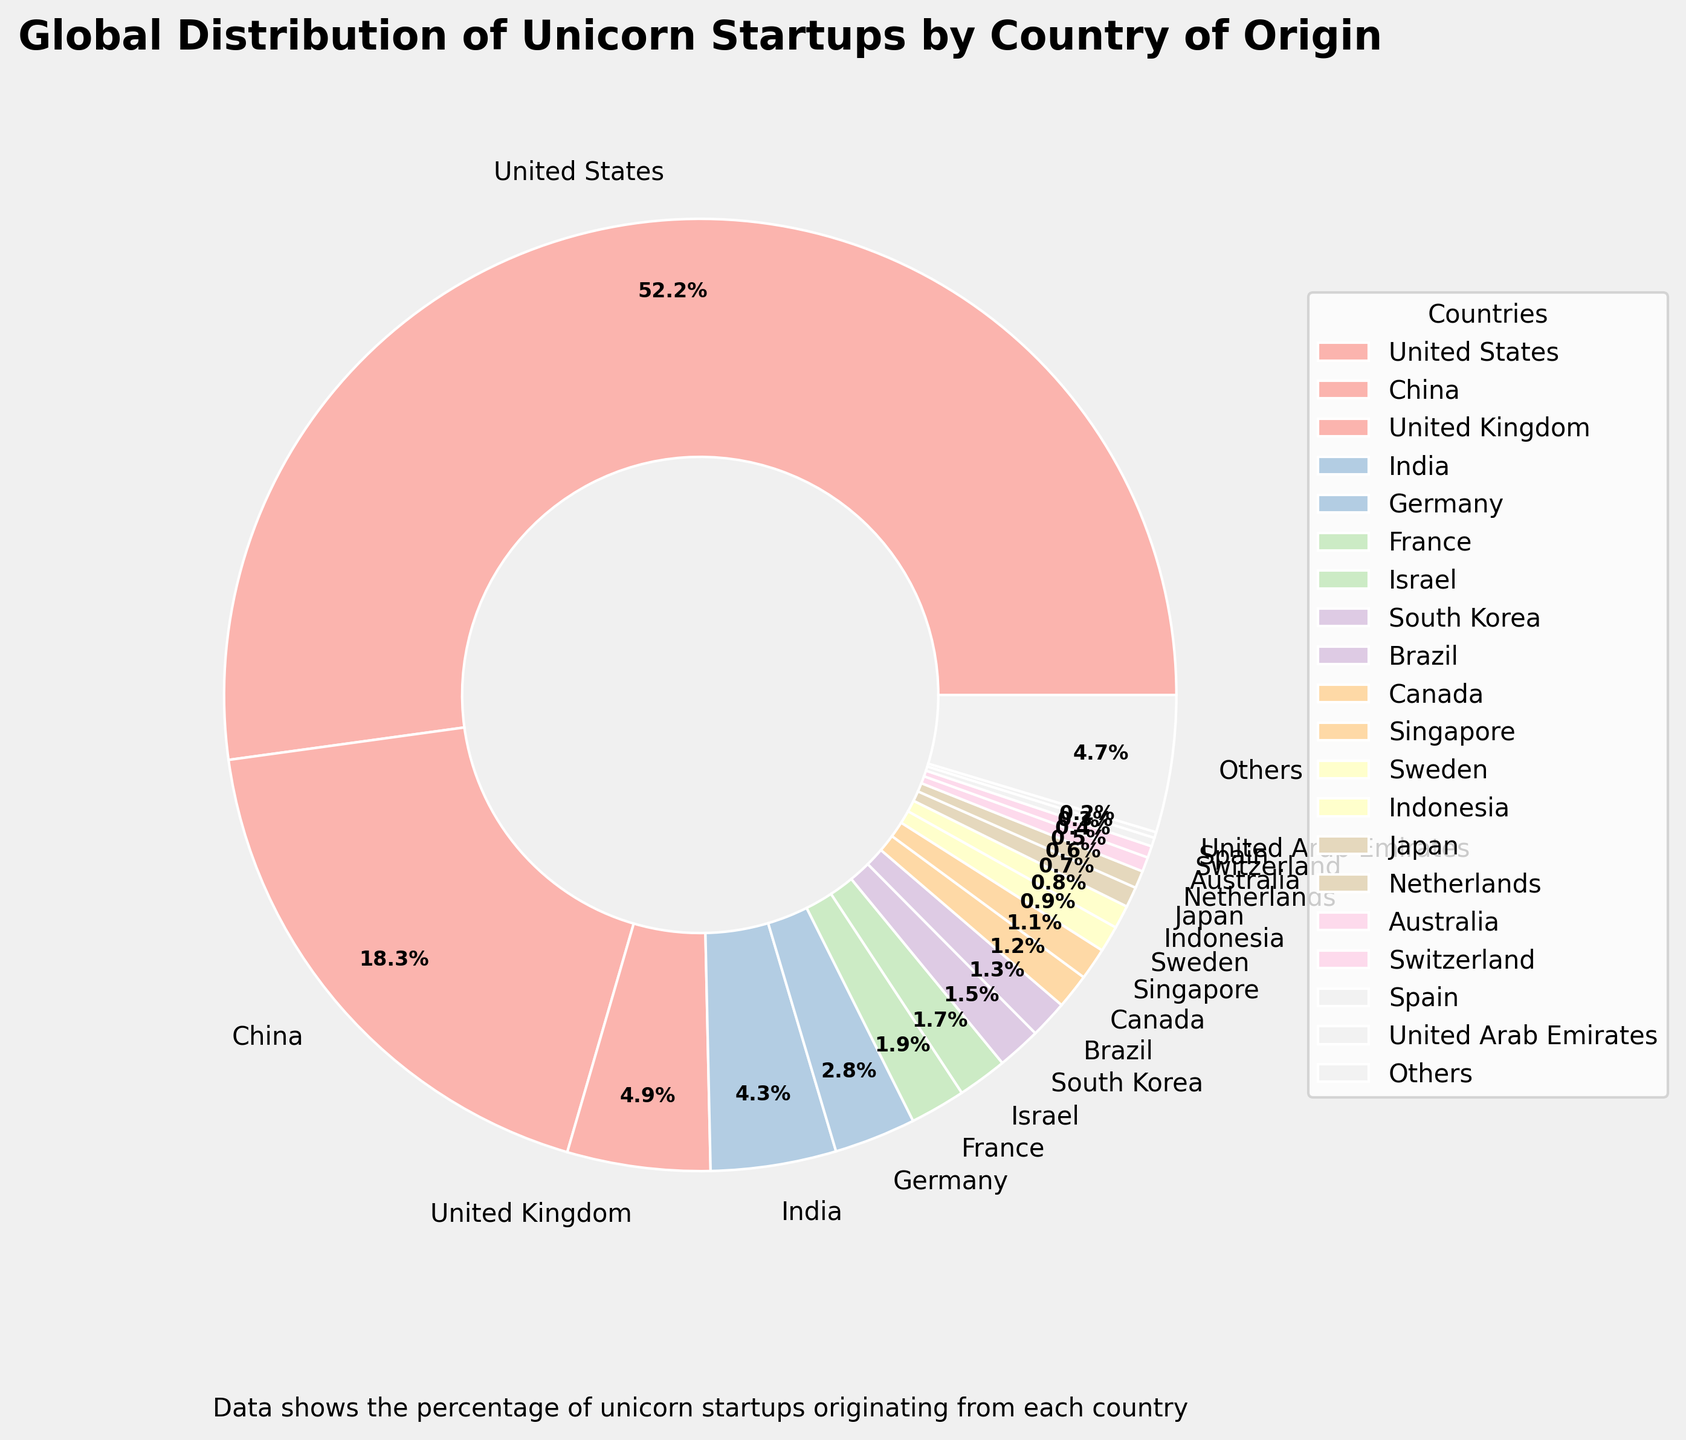Which country has the highest percentage of unicorn startups? The figure shows that the United States has the largest wedge in the pie chart, indicating it has the highest percentage of unicorn startups.
Answer: United States What is the combined percentage of unicorn startups from China and India? According to the figure, China's percentage is 18.5% and India's is 4.3%. Combining these percentages involves adding them together: 18.5% + 4.3% = 22.8%
Answer: 22.8% How does the percentage of unicorn startups from the United Kingdom compare to Germany? The pie chart shows that the United Kingdom has 4.9% and Germany has 2.8%. By comparing these, the United Kingdom's percentage is larger.
Answer: The United Kingdom has a higher percentage Which countries have a percentage of unicorn startups lower than 1%? The figure lists several countries with lower than 1% including Sweden, Indonesia, Japan, Netherlands, Australia, Switzerland, Spain, United Arab Emirates, and "Others".
Answer: Sweden, Indonesia, Japan, Netherlands, Australia, Switzerland, Spain, United Arab Emirates, Others What is the difference in the percentage of unicorn startups between the United States and China? The figure shows that the United States has a percentage of 52.7% and China has 18.5%. The difference is found by subtracting China's percentage from the United States': 52.7% - 18.5% = 34.2%
Answer: 34.2% Which country has the lowest percentage of unicorn startups among those specifically listed? The figure indicates that the United Arab Emirates has the lowest percentage listed with 0.2%.
Answer: United Arab Emirates How much larger is the United States' percentage of unicorn startups compared to the combined percentage of France and Israel? The United States has 52.7%, France has 1.9%, and Israel has 1.7%. Combined, France and Israel have 1.9% + 1.7% = 3.6%. The difference is 52.7% - 3.6% = 49.1%.
Answer: 49.1% Which countries have a percentage of unicorn startups exactly or above 4%? The figure shows that the United States (52.7%), China (18.5%), United Kingdom (4.9%), and India (4.3%) each have percentages 4% or greater.
Answer: United States, China, United Kingdom, India 